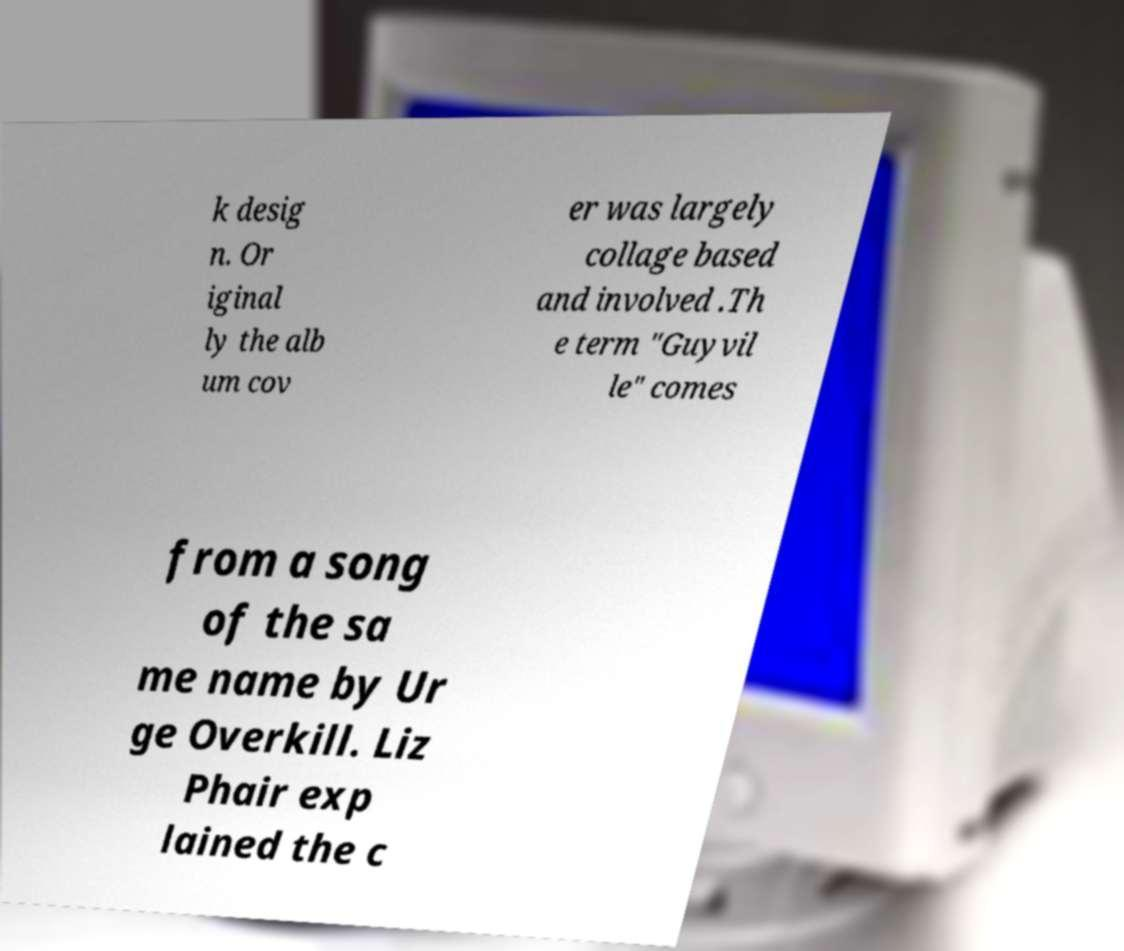I need the written content from this picture converted into text. Can you do that? k desig n. Or iginal ly the alb um cov er was largely collage based and involved .Th e term "Guyvil le" comes from a song of the sa me name by Ur ge Overkill. Liz Phair exp lained the c 